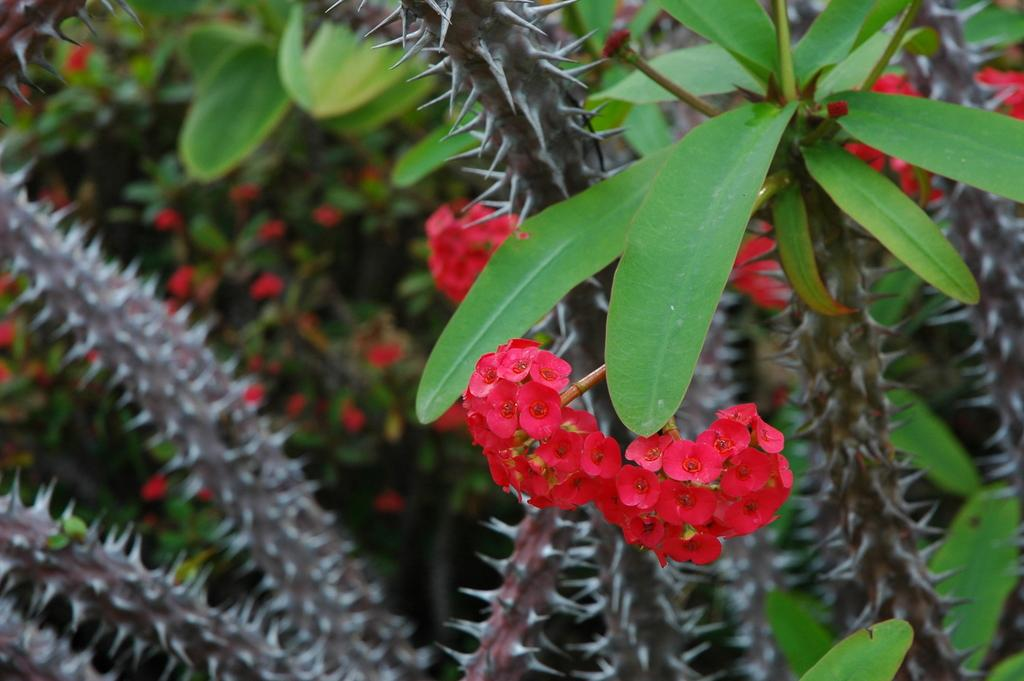What type of flowers can be seen on the plant in the image? There are small red flowers on a plant in the image. What can be observed in the background of the image? There is a blurred image in the background of the image. What type of plant is located at the bottom of the image? There is a cactus plant at the bottom of the image. What songs are being sung by the flowers in the image? There are no songs being sung by the flowers in the image, as flowers do not have the ability to sing. What is the smell of the flowers in the image? The image does not provide information about the smell of the flowers, so it cannot be determined from the image. 